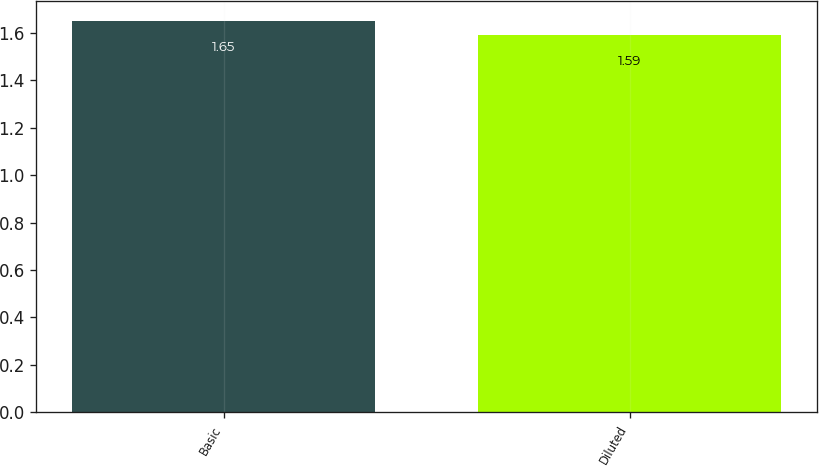<chart> <loc_0><loc_0><loc_500><loc_500><bar_chart><fcel>Basic<fcel>Diluted<nl><fcel>1.65<fcel>1.59<nl></chart> 